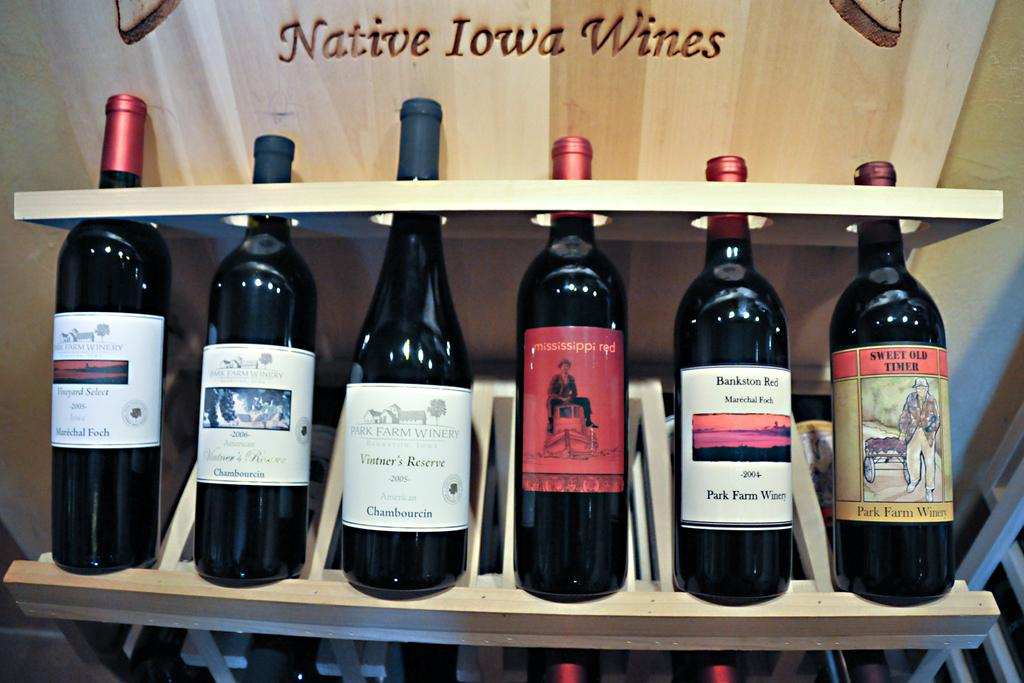<image>
Relay a brief, clear account of the picture shown. Several wines, including Sweet Old Timer and Mississippi Red are on a shelf. 